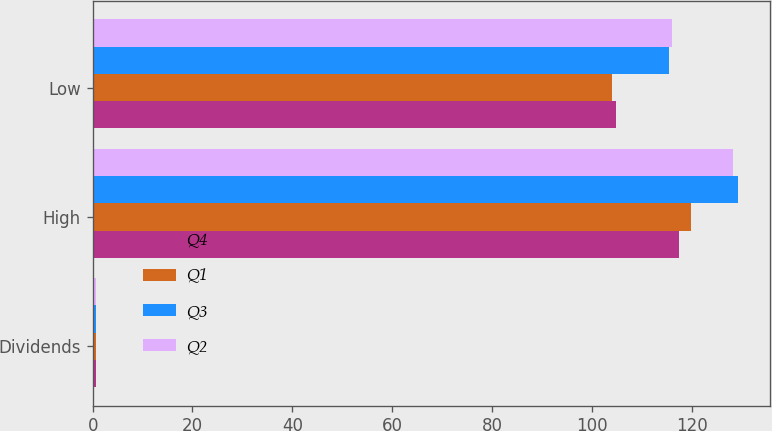Convert chart. <chart><loc_0><loc_0><loc_500><loc_500><stacked_bar_chart><ecel><fcel>Dividends<fcel>High<fcel>Low<nl><fcel>Q4<fcel>0.6<fcel>117.4<fcel>104.77<nl><fcel>Q1<fcel>0.6<fcel>119.82<fcel>104.08<nl><fcel>Q3<fcel>0.6<fcel>129.27<fcel>115.38<nl><fcel>Q2<fcel>0.69<fcel>128.38<fcel>116.06<nl></chart> 